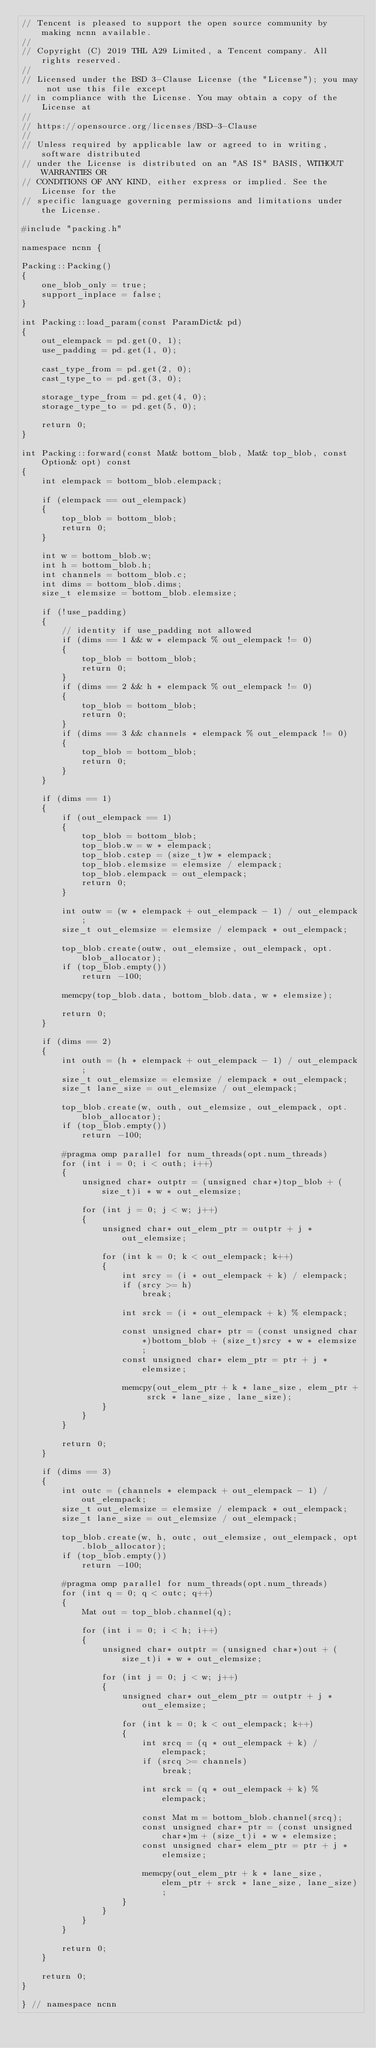Convert code to text. <code><loc_0><loc_0><loc_500><loc_500><_C++_>// Tencent is pleased to support the open source community by making ncnn available.
//
// Copyright (C) 2019 THL A29 Limited, a Tencent company. All rights reserved.
//
// Licensed under the BSD 3-Clause License (the "License"); you may not use this file except
// in compliance with the License. You may obtain a copy of the License at
//
// https://opensource.org/licenses/BSD-3-Clause
//
// Unless required by applicable law or agreed to in writing, software distributed
// under the License is distributed on an "AS IS" BASIS, WITHOUT WARRANTIES OR
// CONDITIONS OF ANY KIND, either express or implied. See the License for the
// specific language governing permissions and limitations under the License.

#include "packing.h"

namespace ncnn {

Packing::Packing()
{
    one_blob_only = true;
    support_inplace = false;
}

int Packing::load_param(const ParamDict& pd)
{
    out_elempack = pd.get(0, 1);
    use_padding = pd.get(1, 0);

    cast_type_from = pd.get(2, 0);
    cast_type_to = pd.get(3, 0);

    storage_type_from = pd.get(4, 0);
    storage_type_to = pd.get(5, 0);

    return 0;
}

int Packing::forward(const Mat& bottom_blob, Mat& top_blob, const Option& opt) const
{
    int elempack = bottom_blob.elempack;

    if (elempack == out_elempack)
    {
        top_blob = bottom_blob;
        return 0;
    }

    int w = bottom_blob.w;
    int h = bottom_blob.h;
    int channels = bottom_blob.c;
    int dims = bottom_blob.dims;
    size_t elemsize = bottom_blob.elemsize;

    if (!use_padding)
    {
        // identity if use_padding not allowed
        if (dims == 1 && w * elempack % out_elempack != 0)
        {
            top_blob = bottom_blob;
            return 0;
        }
        if (dims == 2 && h * elempack % out_elempack != 0)
        {
            top_blob = bottom_blob;
            return 0;
        }
        if (dims == 3 && channels * elempack % out_elempack != 0)
        {
            top_blob = bottom_blob;
            return 0;
        }
    }

    if (dims == 1)
    {
        if (out_elempack == 1)
        {
            top_blob = bottom_blob;
            top_blob.w = w * elempack;
            top_blob.cstep = (size_t)w * elempack;
            top_blob.elemsize = elemsize / elempack;
            top_blob.elempack = out_elempack;
            return 0;
        }

        int outw = (w * elempack + out_elempack - 1) / out_elempack;
        size_t out_elemsize = elemsize / elempack * out_elempack;

        top_blob.create(outw, out_elemsize, out_elempack, opt.blob_allocator);
        if (top_blob.empty())
            return -100;

        memcpy(top_blob.data, bottom_blob.data, w * elemsize);

        return 0;
    }

    if (dims == 2)
    {
        int outh = (h * elempack + out_elempack - 1) / out_elempack;
        size_t out_elemsize = elemsize / elempack * out_elempack;
        size_t lane_size = out_elemsize / out_elempack;

        top_blob.create(w, outh, out_elemsize, out_elempack, opt.blob_allocator);
        if (top_blob.empty())
            return -100;

        #pragma omp parallel for num_threads(opt.num_threads)
        for (int i = 0; i < outh; i++)
        {
            unsigned char* outptr = (unsigned char*)top_blob + (size_t)i * w * out_elemsize;

            for (int j = 0; j < w; j++)
            {
                unsigned char* out_elem_ptr = outptr + j * out_elemsize;

                for (int k = 0; k < out_elempack; k++)
                {
                    int srcy = (i * out_elempack + k) / elempack;
                    if (srcy >= h)
                        break;

                    int srck = (i * out_elempack + k) % elempack;

                    const unsigned char* ptr = (const unsigned char*)bottom_blob + (size_t)srcy * w * elemsize;
                    const unsigned char* elem_ptr = ptr + j * elemsize;

                    memcpy(out_elem_ptr + k * lane_size, elem_ptr + srck * lane_size, lane_size);
                }
            }
        }

        return 0;
    }

    if (dims == 3)
    {
        int outc = (channels * elempack + out_elempack - 1) / out_elempack;
        size_t out_elemsize = elemsize / elempack * out_elempack;
        size_t lane_size = out_elemsize / out_elempack;

        top_blob.create(w, h, outc, out_elemsize, out_elempack, opt.blob_allocator);
        if (top_blob.empty())
            return -100;

        #pragma omp parallel for num_threads(opt.num_threads)
        for (int q = 0; q < outc; q++)
        {
            Mat out = top_blob.channel(q);

            for (int i = 0; i < h; i++)
            {
                unsigned char* outptr = (unsigned char*)out + (size_t)i * w * out_elemsize;

                for (int j = 0; j < w; j++)
                {
                    unsigned char* out_elem_ptr = outptr + j * out_elemsize;

                    for (int k = 0; k < out_elempack; k++)
                    {
                        int srcq = (q * out_elempack + k) / elempack;
                        if (srcq >= channels)
                            break;

                        int srck = (q * out_elempack + k) % elempack;

                        const Mat m = bottom_blob.channel(srcq);
                        const unsigned char* ptr = (const unsigned char*)m + (size_t)i * w * elemsize;
                        const unsigned char* elem_ptr = ptr + j * elemsize;

                        memcpy(out_elem_ptr + k * lane_size, elem_ptr + srck * lane_size, lane_size);
                    }
                }
            }
        }

        return 0;
    }

    return 0;
}

} // namespace ncnn
</code> 